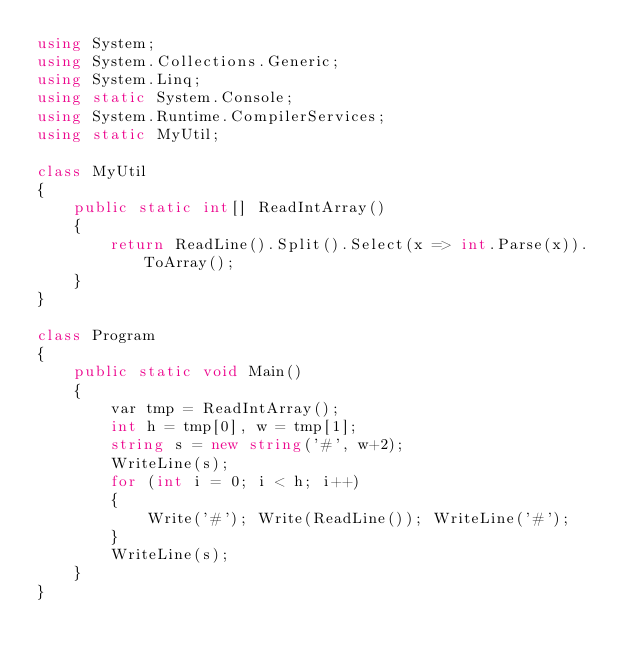<code> <loc_0><loc_0><loc_500><loc_500><_C#_>using System;
using System.Collections.Generic;
using System.Linq;
using static System.Console;
using System.Runtime.CompilerServices;
using static MyUtil;

class MyUtil
{
    public static int[] ReadIntArray()
    {
        return ReadLine().Split().Select(x => int.Parse(x)).ToArray();
    }
}

class Program
{
    public static void Main()
    {
        var tmp = ReadIntArray();
        int h = tmp[0], w = tmp[1];
        string s = new string('#', w+2);
        WriteLine(s);
        for (int i = 0; i < h; i++)
        {
            Write('#'); Write(ReadLine()); WriteLine('#');
        }
        WriteLine(s);
    }
}</code> 